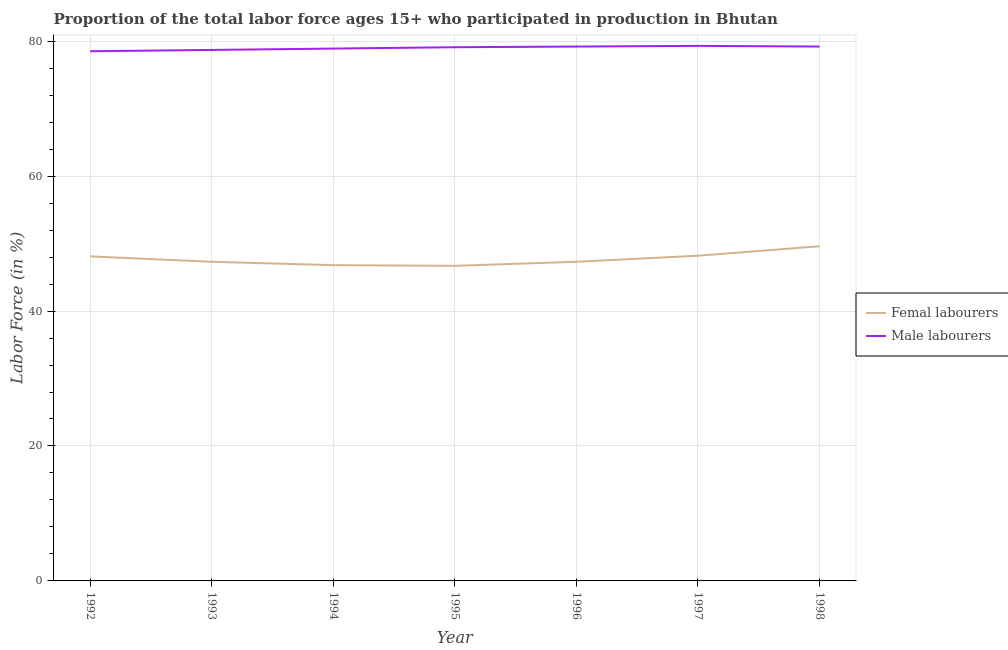How many different coloured lines are there?
Your answer should be compact. 2. Does the line corresponding to percentage of female labor force intersect with the line corresponding to percentage of male labour force?
Provide a succinct answer. No. Is the number of lines equal to the number of legend labels?
Your answer should be very brief. Yes. What is the percentage of male labour force in 1992?
Provide a short and direct response. 78.5. Across all years, what is the maximum percentage of female labor force?
Give a very brief answer. 49.6. Across all years, what is the minimum percentage of male labour force?
Your answer should be very brief. 78.5. What is the total percentage of female labor force in the graph?
Your answer should be compact. 334. What is the difference between the percentage of female labor force in 1995 and the percentage of male labour force in 1993?
Your answer should be very brief. -32. What is the average percentage of male labour force per year?
Provide a succinct answer. 78.99. In the year 1993, what is the difference between the percentage of female labor force and percentage of male labour force?
Make the answer very short. -31.4. In how many years, is the percentage of male labour force greater than 12 %?
Provide a short and direct response. 7. What is the ratio of the percentage of female labor force in 1994 to that in 1996?
Your response must be concise. 0.99. Is the percentage of male labour force in 1993 less than that in 1994?
Provide a succinct answer. Yes. Is the difference between the percentage of female labor force in 1995 and 1998 greater than the difference between the percentage of male labour force in 1995 and 1998?
Keep it short and to the point. No. What is the difference between the highest and the second highest percentage of male labour force?
Ensure brevity in your answer.  0.1. What is the difference between the highest and the lowest percentage of male labour force?
Give a very brief answer. 0.8. Is the sum of the percentage of female labor force in 1994 and 1997 greater than the maximum percentage of male labour force across all years?
Offer a terse response. Yes. Does the percentage of male labour force monotonically increase over the years?
Your answer should be compact. No. Is the percentage of female labor force strictly less than the percentage of male labour force over the years?
Offer a very short reply. Yes. How many lines are there?
Offer a terse response. 2. How many years are there in the graph?
Offer a terse response. 7. What is the difference between two consecutive major ticks on the Y-axis?
Provide a succinct answer. 20. How many legend labels are there?
Ensure brevity in your answer.  2. What is the title of the graph?
Provide a short and direct response. Proportion of the total labor force ages 15+ who participated in production in Bhutan. Does "Primary school" appear as one of the legend labels in the graph?
Provide a succinct answer. No. What is the label or title of the Y-axis?
Your response must be concise. Labor Force (in %). What is the Labor Force (in %) of Femal labourers in 1992?
Your answer should be compact. 48.1. What is the Labor Force (in %) in Male labourers in 1992?
Offer a very short reply. 78.5. What is the Labor Force (in %) of Femal labourers in 1993?
Provide a short and direct response. 47.3. What is the Labor Force (in %) in Male labourers in 1993?
Give a very brief answer. 78.7. What is the Labor Force (in %) of Femal labourers in 1994?
Make the answer very short. 46.8. What is the Labor Force (in %) in Male labourers in 1994?
Ensure brevity in your answer.  78.9. What is the Labor Force (in %) in Femal labourers in 1995?
Your response must be concise. 46.7. What is the Labor Force (in %) in Male labourers in 1995?
Offer a very short reply. 79.1. What is the Labor Force (in %) in Femal labourers in 1996?
Make the answer very short. 47.3. What is the Labor Force (in %) in Male labourers in 1996?
Give a very brief answer. 79.2. What is the Labor Force (in %) of Femal labourers in 1997?
Ensure brevity in your answer.  48.2. What is the Labor Force (in %) of Male labourers in 1997?
Your response must be concise. 79.3. What is the Labor Force (in %) of Femal labourers in 1998?
Ensure brevity in your answer.  49.6. What is the Labor Force (in %) in Male labourers in 1998?
Offer a terse response. 79.2. Across all years, what is the maximum Labor Force (in %) in Femal labourers?
Your answer should be very brief. 49.6. Across all years, what is the maximum Labor Force (in %) of Male labourers?
Provide a succinct answer. 79.3. Across all years, what is the minimum Labor Force (in %) of Femal labourers?
Offer a terse response. 46.7. Across all years, what is the minimum Labor Force (in %) in Male labourers?
Provide a succinct answer. 78.5. What is the total Labor Force (in %) of Femal labourers in the graph?
Give a very brief answer. 334. What is the total Labor Force (in %) of Male labourers in the graph?
Provide a short and direct response. 552.9. What is the difference between the Labor Force (in %) of Femal labourers in 1992 and that in 1993?
Offer a terse response. 0.8. What is the difference between the Labor Force (in %) in Male labourers in 1992 and that in 1995?
Your answer should be very brief. -0.6. What is the difference between the Labor Force (in %) of Femal labourers in 1992 and that in 1997?
Offer a very short reply. -0.1. What is the difference between the Labor Force (in %) in Male labourers in 1993 and that in 1995?
Offer a terse response. -0.4. What is the difference between the Labor Force (in %) in Femal labourers in 1993 and that in 1996?
Keep it short and to the point. 0. What is the difference between the Labor Force (in %) of Femal labourers in 1993 and that in 1998?
Keep it short and to the point. -2.3. What is the difference between the Labor Force (in %) in Male labourers in 1994 and that in 1995?
Offer a terse response. -0.2. What is the difference between the Labor Force (in %) of Male labourers in 1994 and that in 1996?
Provide a succinct answer. -0.3. What is the difference between the Labor Force (in %) in Male labourers in 1994 and that in 1997?
Ensure brevity in your answer.  -0.4. What is the difference between the Labor Force (in %) in Femal labourers in 1994 and that in 1998?
Keep it short and to the point. -2.8. What is the difference between the Labor Force (in %) of Femal labourers in 1995 and that in 1998?
Provide a succinct answer. -2.9. What is the difference between the Labor Force (in %) in Male labourers in 1995 and that in 1998?
Your answer should be compact. -0.1. What is the difference between the Labor Force (in %) in Femal labourers in 1996 and that in 1997?
Your answer should be very brief. -0.9. What is the difference between the Labor Force (in %) in Male labourers in 1996 and that in 1997?
Your answer should be compact. -0.1. What is the difference between the Labor Force (in %) of Femal labourers in 1996 and that in 1998?
Offer a very short reply. -2.3. What is the difference between the Labor Force (in %) of Male labourers in 1997 and that in 1998?
Provide a short and direct response. 0.1. What is the difference between the Labor Force (in %) in Femal labourers in 1992 and the Labor Force (in %) in Male labourers in 1993?
Offer a very short reply. -30.6. What is the difference between the Labor Force (in %) in Femal labourers in 1992 and the Labor Force (in %) in Male labourers in 1994?
Your answer should be compact. -30.8. What is the difference between the Labor Force (in %) of Femal labourers in 1992 and the Labor Force (in %) of Male labourers in 1995?
Keep it short and to the point. -31. What is the difference between the Labor Force (in %) in Femal labourers in 1992 and the Labor Force (in %) in Male labourers in 1996?
Provide a succinct answer. -31.1. What is the difference between the Labor Force (in %) of Femal labourers in 1992 and the Labor Force (in %) of Male labourers in 1997?
Offer a terse response. -31.2. What is the difference between the Labor Force (in %) of Femal labourers in 1992 and the Labor Force (in %) of Male labourers in 1998?
Your answer should be very brief. -31.1. What is the difference between the Labor Force (in %) in Femal labourers in 1993 and the Labor Force (in %) in Male labourers in 1994?
Make the answer very short. -31.6. What is the difference between the Labor Force (in %) of Femal labourers in 1993 and the Labor Force (in %) of Male labourers in 1995?
Give a very brief answer. -31.8. What is the difference between the Labor Force (in %) in Femal labourers in 1993 and the Labor Force (in %) in Male labourers in 1996?
Offer a terse response. -31.9. What is the difference between the Labor Force (in %) in Femal labourers in 1993 and the Labor Force (in %) in Male labourers in 1997?
Give a very brief answer. -32. What is the difference between the Labor Force (in %) in Femal labourers in 1993 and the Labor Force (in %) in Male labourers in 1998?
Give a very brief answer. -31.9. What is the difference between the Labor Force (in %) in Femal labourers in 1994 and the Labor Force (in %) in Male labourers in 1995?
Keep it short and to the point. -32.3. What is the difference between the Labor Force (in %) of Femal labourers in 1994 and the Labor Force (in %) of Male labourers in 1996?
Provide a succinct answer. -32.4. What is the difference between the Labor Force (in %) in Femal labourers in 1994 and the Labor Force (in %) in Male labourers in 1997?
Ensure brevity in your answer.  -32.5. What is the difference between the Labor Force (in %) in Femal labourers in 1994 and the Labor Force (in %) in Male labourers in 1998?
Your answer should be compact. -32.4. What is the difference between the Labor Force (in %) in Femal labourers in 1995 and the Labor Force (in %) in Male labourers in 1996?
Offer a very short reply. -32.5. What is the difference between the Labor Force (in %) in Femal labourers in 1995 and the Labor Force (in %) in Male labourers in 1997?
Your answer should be very brief. -32.6. What is the difference between the Labor Force (in %) of Femal labourers in 1995 and the Labor Force (in %) of Male labourers in 1998?
Your answer should be compact. -32.5. What is the difference between the Labor Force (in %) of Femal labourers in 1996 and the Labor Force (in %) of Male labourers in 1997?
Keep it short and to the point. -32. What is the difference between the Labor Force (in %) of Femal labourers in 1996 and the Labor Force (in %) of Male labourers in 1998?
Keep it short and to the point. -31.9. What is the difference between the Labor Force (in %) in Femal labourers in 1997 and the Labor Force (in %) in Male labourers in 1998?
Your answer should be compact. -31. What is the average Labor Force (in %) in Femal labourers per year?
Offer a terse response. 47.71. What is the average Labor Force (in %) in Male labourers per year?
Ensure brevity in your answer.  78.99. In the year 1992, what is the difference between the Labor Force (in %) in Femal labourers and Labor Force (in %) in Male labourers?
Provide a succinct answer. -30.4. In the year 1993, what is the difference between the Labor Force (in %) in Femal labourers and Labor Force (in %) in Male labourers?
Give a very brief answer. -31.4. In the year 1994, what is the difference between the Labor Force (in %) of Femal labourers and Labor Force (in %) of Male labourers?
Provide a short and direct response. -32.1. In the year 1995, what is the difference between the Labor Force (in %) in Femal labourers and Labor Force (in %) in Male labourers?
Give a very brief answer. -32.4. In the year 1996, what is the difference between the Labor Force (in %) of Femal labourers and Labor Force (in %) of Male labourers?
Provide a succinct answer. -31.9. In the year 1997, what is the difference between the Labor Force (in %) in Femal labourers and Labor Force (in %) in Male labourers?
Offer a terse response. -31.1. In the year 1998, what is the difference between the Labor Force (in %) in Femal labourers and Labor Force (in %) in Male labourers?
Provide a succinct answer. -29.6. What is the ratio of the Labor Force (in %) in Femal labourers in 1992 to that in 1993?
Give a very brief answer. 1.02. What is the ratio of the Labor Force (in %) of Male labourers in 1992 to that in 1993?
Your response must be concise. 1. What is the ratio of the Labor Force (in %) in Femal labourers in 1992 to that in 1994?
Offer a very short reply. 1.03. What is the ratio of the Labor Force (in %) in Male labourers in 1992 to that in 1994?
Offer a very short reply. 0.99. What is the ratio of the Labor Force (in %) in Male labourers in 1992 to that in 1995?
Your response must be concise. 0.99. What is the ratio of the Labor Force (in %) of Femal labourers in 1992 to that in 1996?
Give a very brief answer. 1.02. What is the ratio of the Labor Force (in %) in Male labourers in 1992 to that in 1997?
Ensure brevity in your answer.  0.99. What is the ratio of the Labor Force (in %) in Femal labourers in 1992 to that in 1998?
Provide a succinct answer. 0.97. What is the ratio of the Labor Force (in %) in Male labourers in 1992 to that in 1998?
Provide a short and direct response. 0.99. What is the ratio of the Labor Force (in %) of Femal labourers in 1993 to that in 1994?
Provide a succinct answer. 1.01. What is the ratio of the Labor Force (in %) in Male labourers in 1993 to that in 1994?
Make the answer very short. 1. What is the ratio of the Labor Force (in %) of Femal labourers in 1993 to that in 1995?
Keep it short and to the point. 1.01. What is the ratio of the Labor Force (in %) of Male labourers in 1993 to that in 1996?
Ensure brevity in your answer.  0.99. What is the ratio of the Labor Force (in %) of Femal labourers in 1993 to that in 1997?
Give a very brief answer. 0.98. What is the ratio of the Labor Force (in %) in Male labourers in 1993 to that in 1997?
Provide a succinct answer. 0.99. What is the ratio of the Labor Force (in %) in Femal labourers in 1993 to that in 1998?
Your answer should be very brief. 0.95. What is the ratio of the Labor Force (in %) of Male labourers in 1994 to that in 1995?
Your response must be concise. 1. What is the ratio of the Labor Force (in %) of Femal labourers in 1994 to that in 1998?
Your answer should be very brief. 0.94. What is the ratio of the Labor Force (in %) in Femal labourers in 1995 to that in 1996?
Your answer should be compact. 0.99. What is the ratio of the Labor Force (in %) of Male labourers in 1995 to that in 1996?
Keep it short and to the point. 1. What is the ratio of the Labor Force (in %) in Femal labourers in 1995 to that in 1997?
Your answer should be compact. 0.97. What is the ratio of the Labor Force (in %) of Femal labourers in 1995 to that in 1998?
Offer a terse response. 0.94. What is the ratio of the Labor Force (in %) in Femal labourers in 1996 to that in 1997?
Offer a terse response. 0.98. What is the ratio of the Labor Force (in %) of Male labourers in 1996 to that in 1997?
Offer a terse response. 1. What is the ratio of the Labor Force (in %) in Femal labourers in 1996 to that in 1998?
Your answer should be very brief. 0.95. What is the ratio of the Labor Force (in %) in Femal labourers in 1997 to that in 1998?
Your response must be concise. 0.97. What is the difference between the highest and the lowest Labor Force (in %) of Femal labourers?
Offer a very short reply. 2.9. 